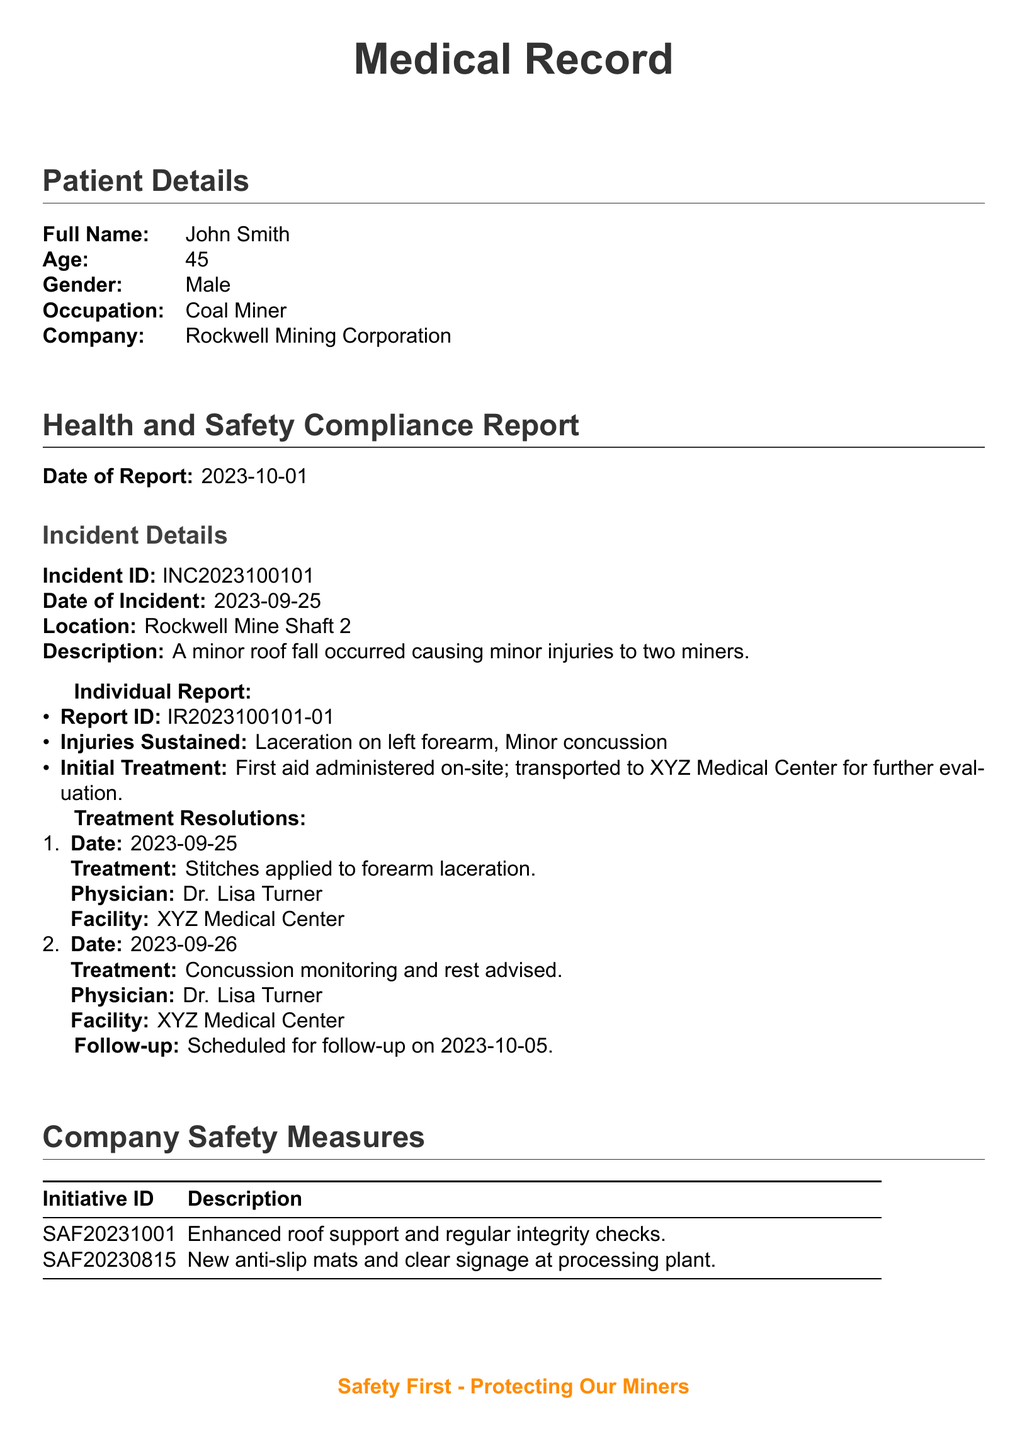What is the full name of the patient? The full name of the patient is provided in the Patient Details section.
Answer: John Smith What is the age of the patient? The age of the patient can be found in the Patient Details section.
Answer: 45 What was the date of the incident? The date of the incident is specified in the Incident Details section.
Answer: 2023-09-25 How many injuries were sustained in the incident? The number of injuries is listed in the Individual Report under Injuries Sustained.
Answer: Two What treatment was given for the forearm laceration? The treatment for the forearm laceration is detailed in the Treatment Resolutions section.
Answer: Stitches applied Who was the physician that treated the miners? The physician's name appears in the Treatment Resolutions for both treatments.
Answer: Dr. Lisa Turner What safety initiative was implemented on 2023-10-01? The safety initiative details are provided in the Company Safety Measures section.
Answer: Enhanced roof support and regular integrity checks What type of injury was reported along with the laceration? The type of injury associated with the laceration is mentioned in the Individual Report.
Answer: Minor concussion When is the follow-up appointment scheduled? The follow-up date is mentioned at the end of the individual report.
Answer: 2023-10-05 